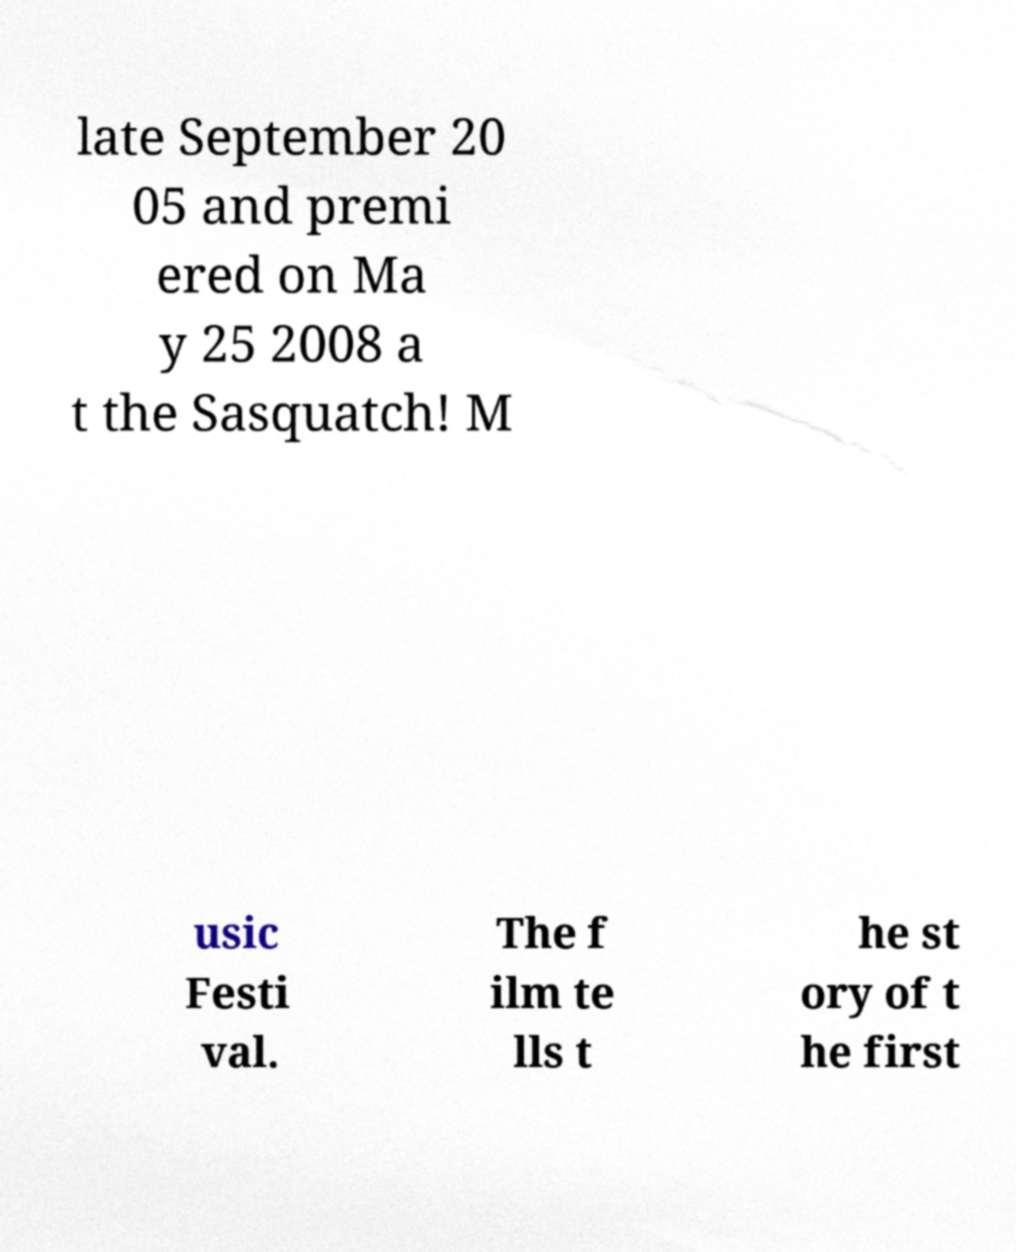Could you extract and type out the text from this image? late September 20 05 and premi ered on Ma y 25 2008 a t the Sasquatch! M usic Festi val. The f ilm te lls t he st ory of t he first 